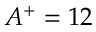<formula> <loc_0><loc_0><loc_500><loc_500>A ^ { + } = 1 2</formula> 